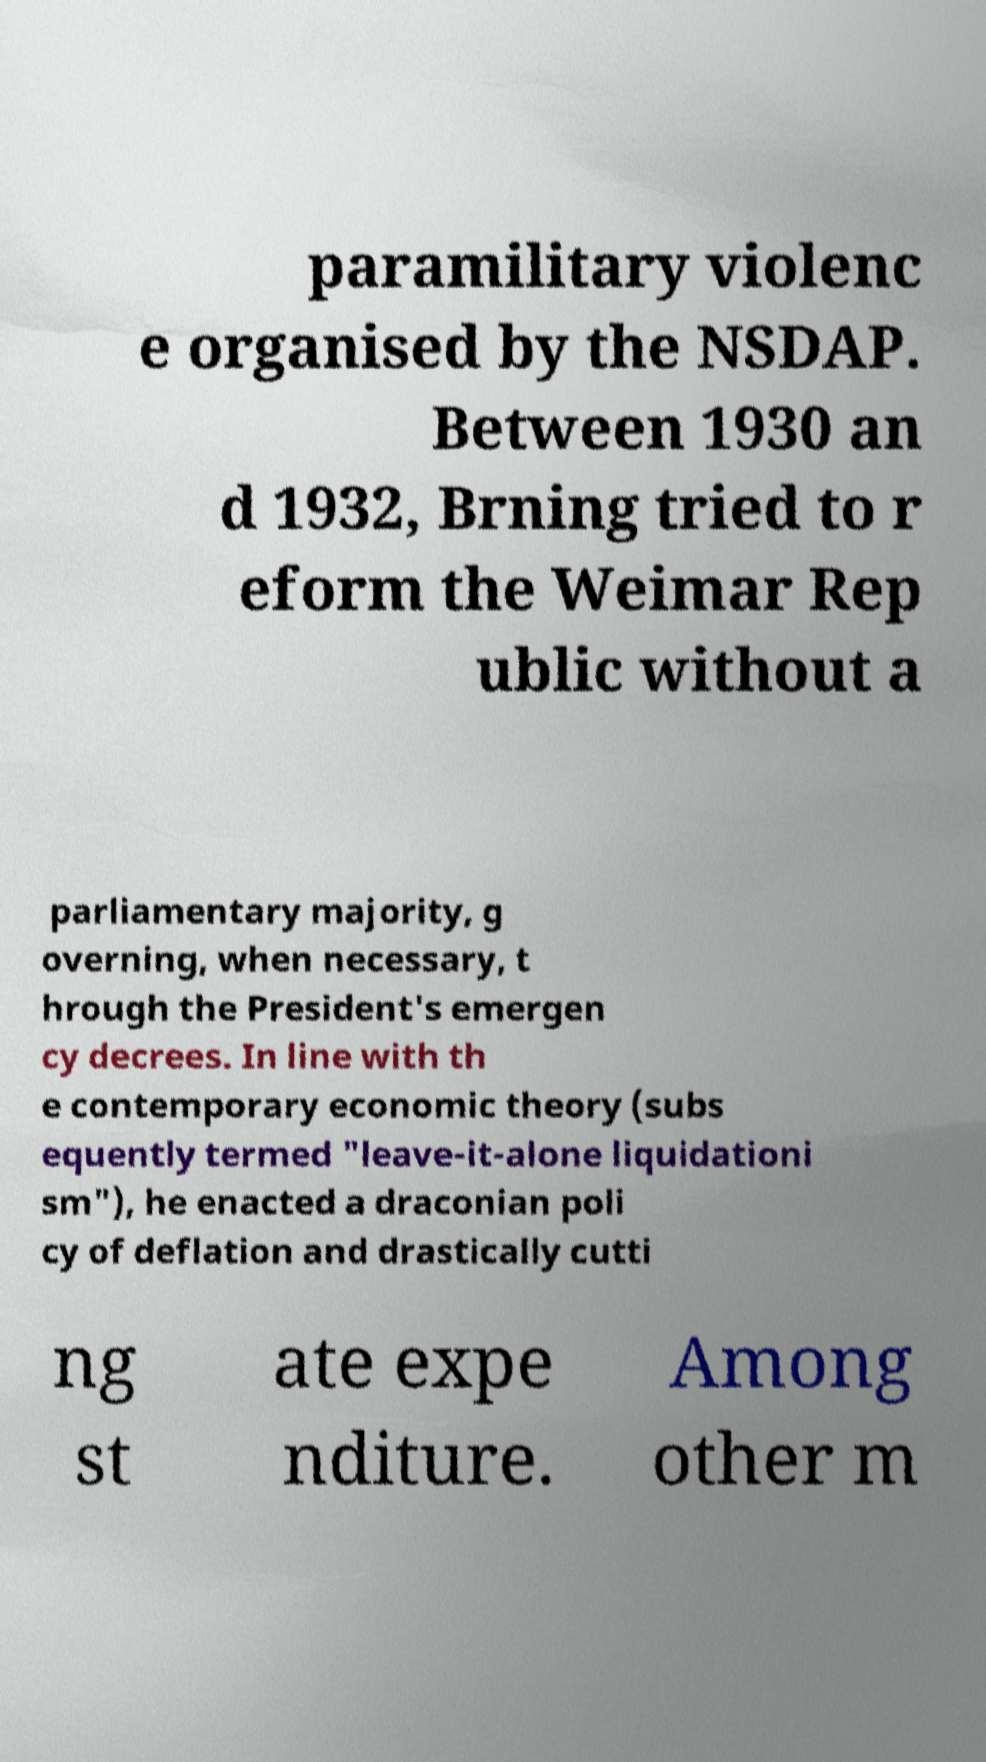Can you accurately transcribe the text from the provided image for me? paramilitary violenc e organised by the NSDAP. Between 1930 an d 1932, Brning tried to r eform the Weimar Rep ublic without a parliamentary majority, g overning, when necessary, t hrough the President's emergen cy decrees. In line with th e contemporary economic theory (subs equently termed "leave-it-alone liquidationi sm"), he enacted a draconian poli cy of deflation and drastically cutti ng st ate expe nditure. Among other m 